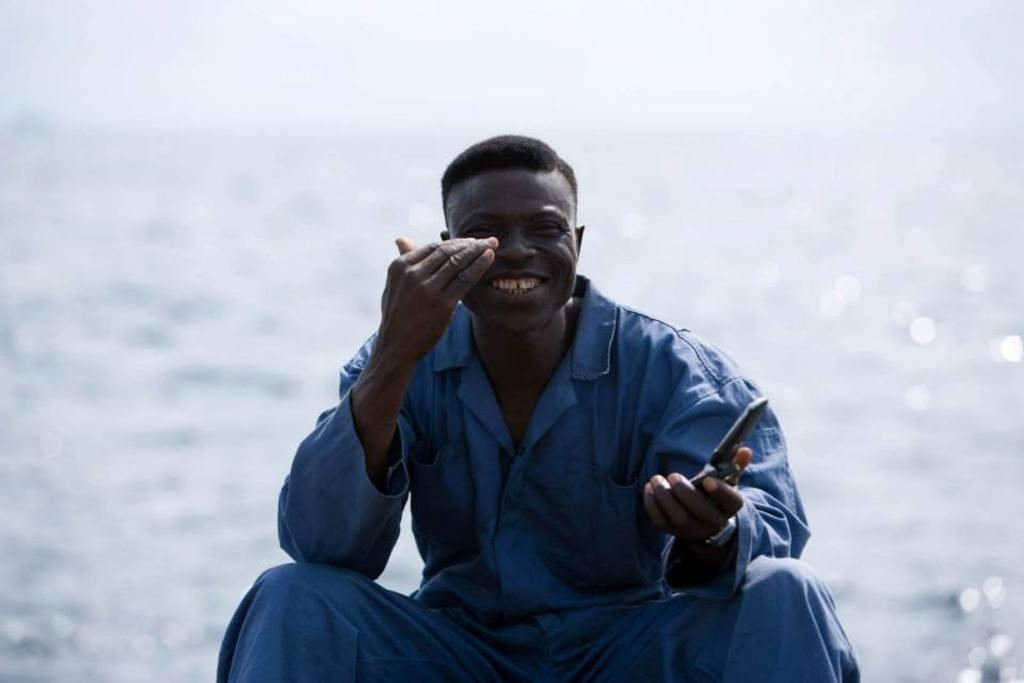Who is the main subject in the picture? There is a person in the center of the picture. What is the person wearing? The person is wearing a blue dress. What is the person holding in the picture? The person is holding a knife. What can be seen in the background of the image? There is a water body in the background of the image. What type of pickle is the person using the knife to cut in the image? There is no pickle present in the image, and the person is not using the knife to cut anything. 